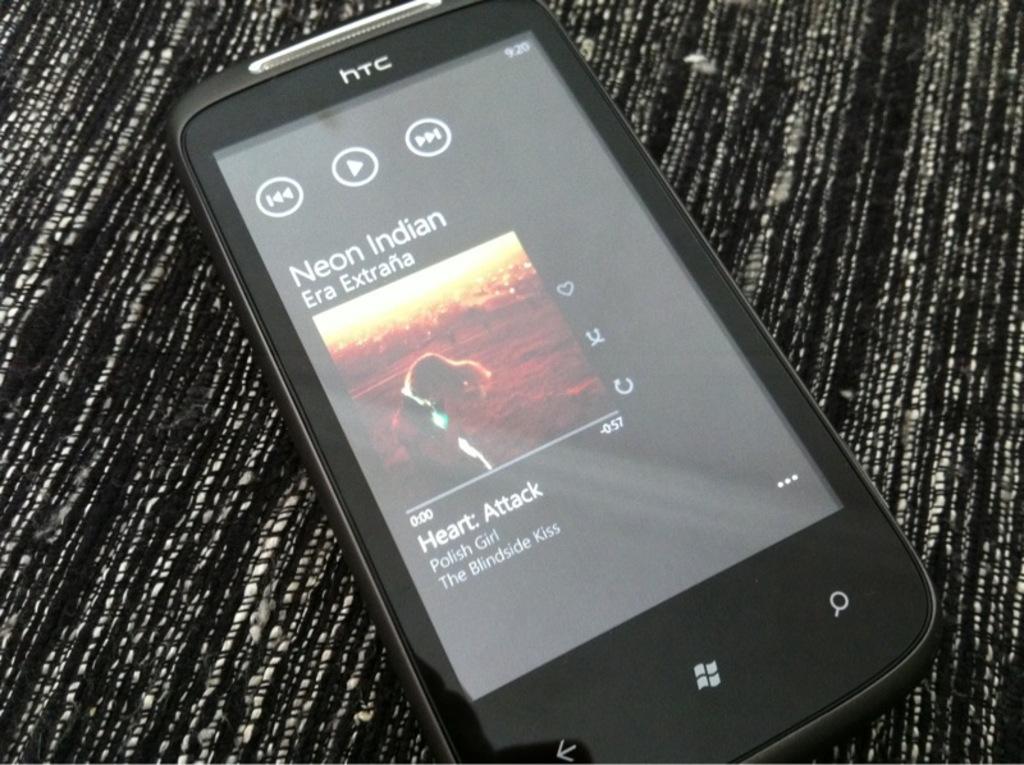What song is playing on the phone?
Provide a short and direct response. Heart attack. 